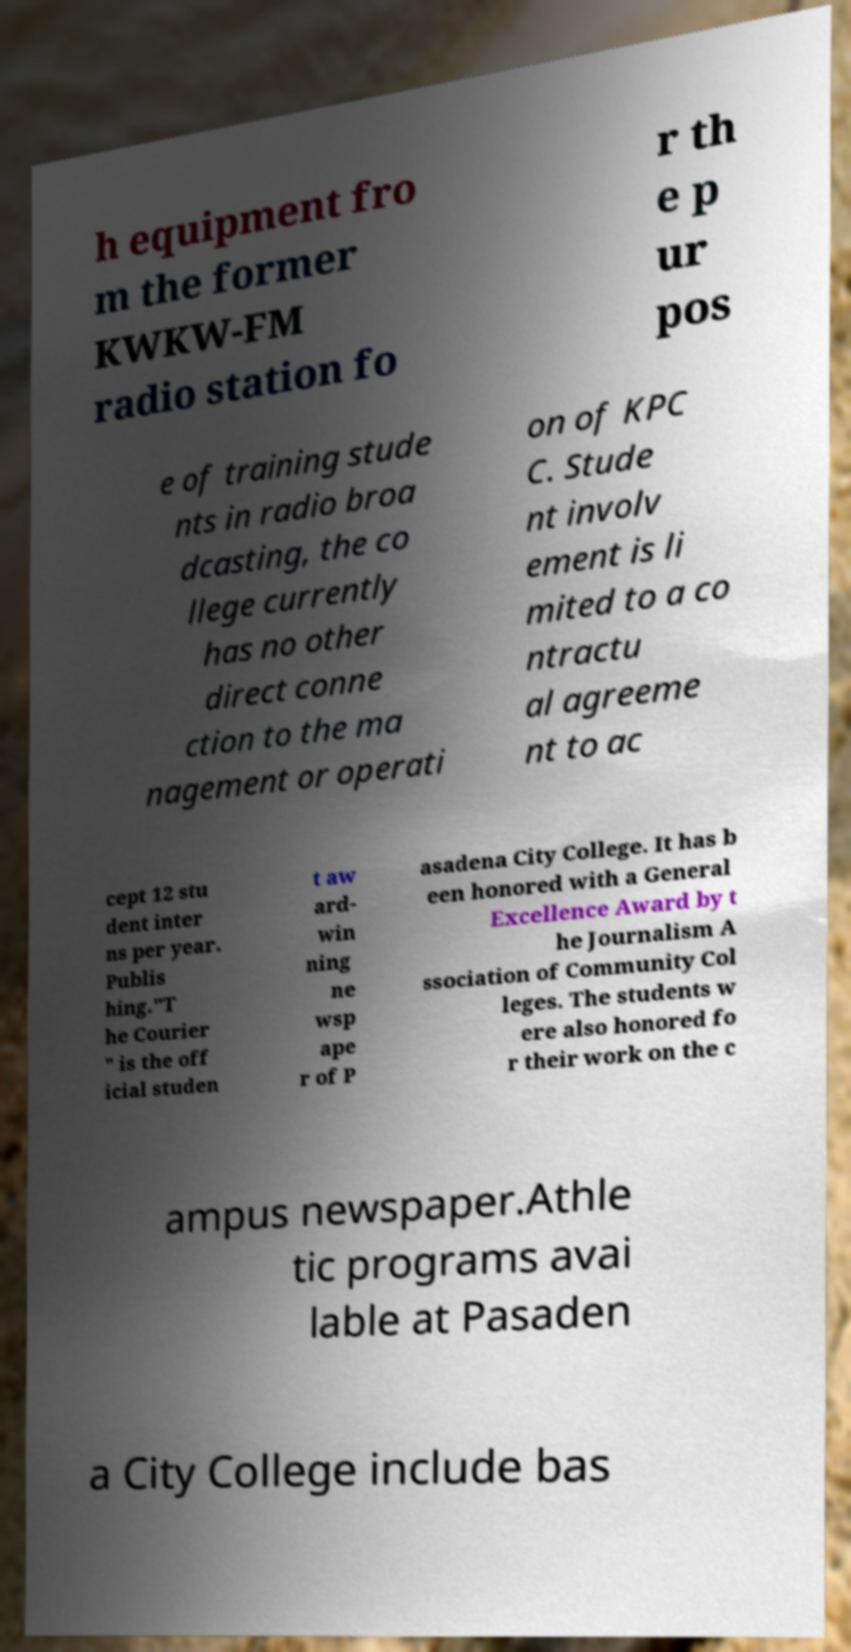I need the written content from this picture converted into text. Can you do that? h equipment fro m the former KWKW-FM radio station fo r th e p ur pos e of training stude nts in radio broa dcasting, the co llege currently has no other direct conne ction to the ma nagement or operati on of KPC C. Stude nt involv ement is li mited to a co ntractu al agreeme nt to ac cept 12 stu dent inter ns per year. Publis hing."T he Courier " is the off icial studen t aw ard- win ning ne wsp ape r of P asadena City College. It has b een honored with a General Excellence Award by t he Journalism A ssociation of Community Col leges. The students w ere also honored fo r their work on the c ampus newspaper.Athle tic programs avai lable at Pasaden a City College include bas 